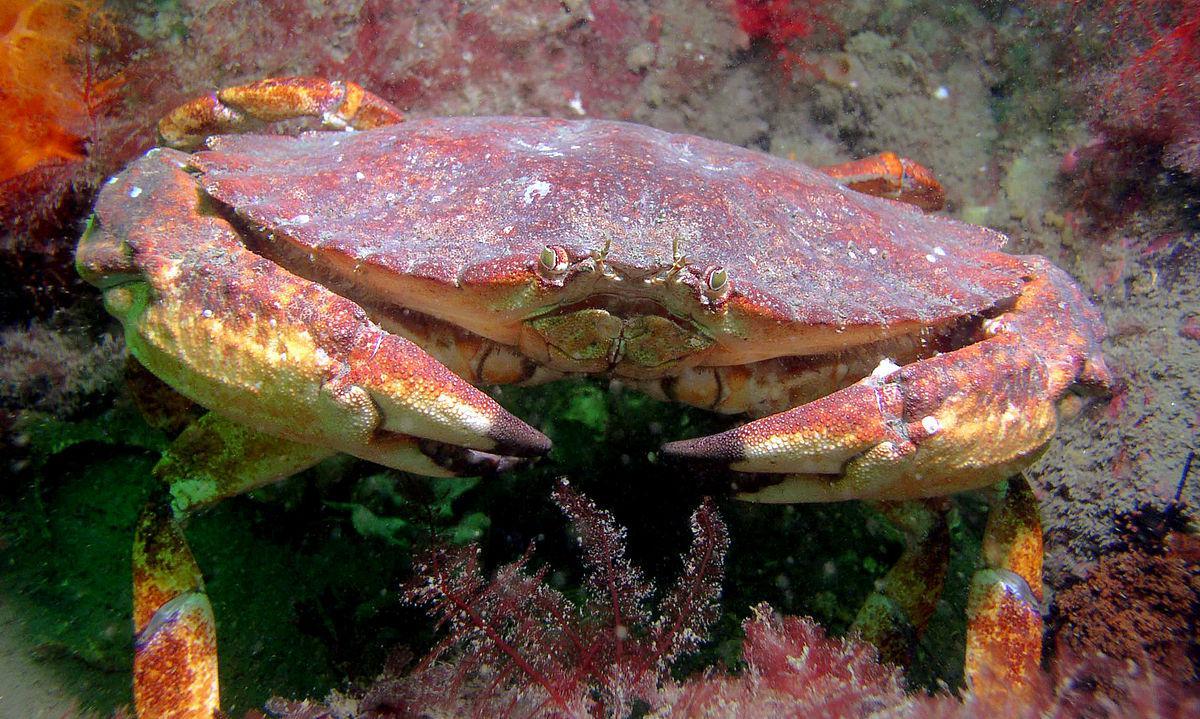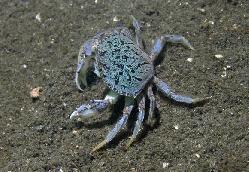The first image is the image on the left, the second image is the image on the right. Examine the images to the left and right. Is the description "in at least one image there is a single carb facing forward in water with coral in the background." accurate? Answer yes or no. Yes. The first image is the image on the left, the second image is the image on the right. Examine the images to the left and right. Is the description "The right image shows the top view of a crab with a grainy grayish shell, and the left image shows at least one crab with a pinker shell and yellow-tinted claws." accurate? Answer yes or no. Yes. 